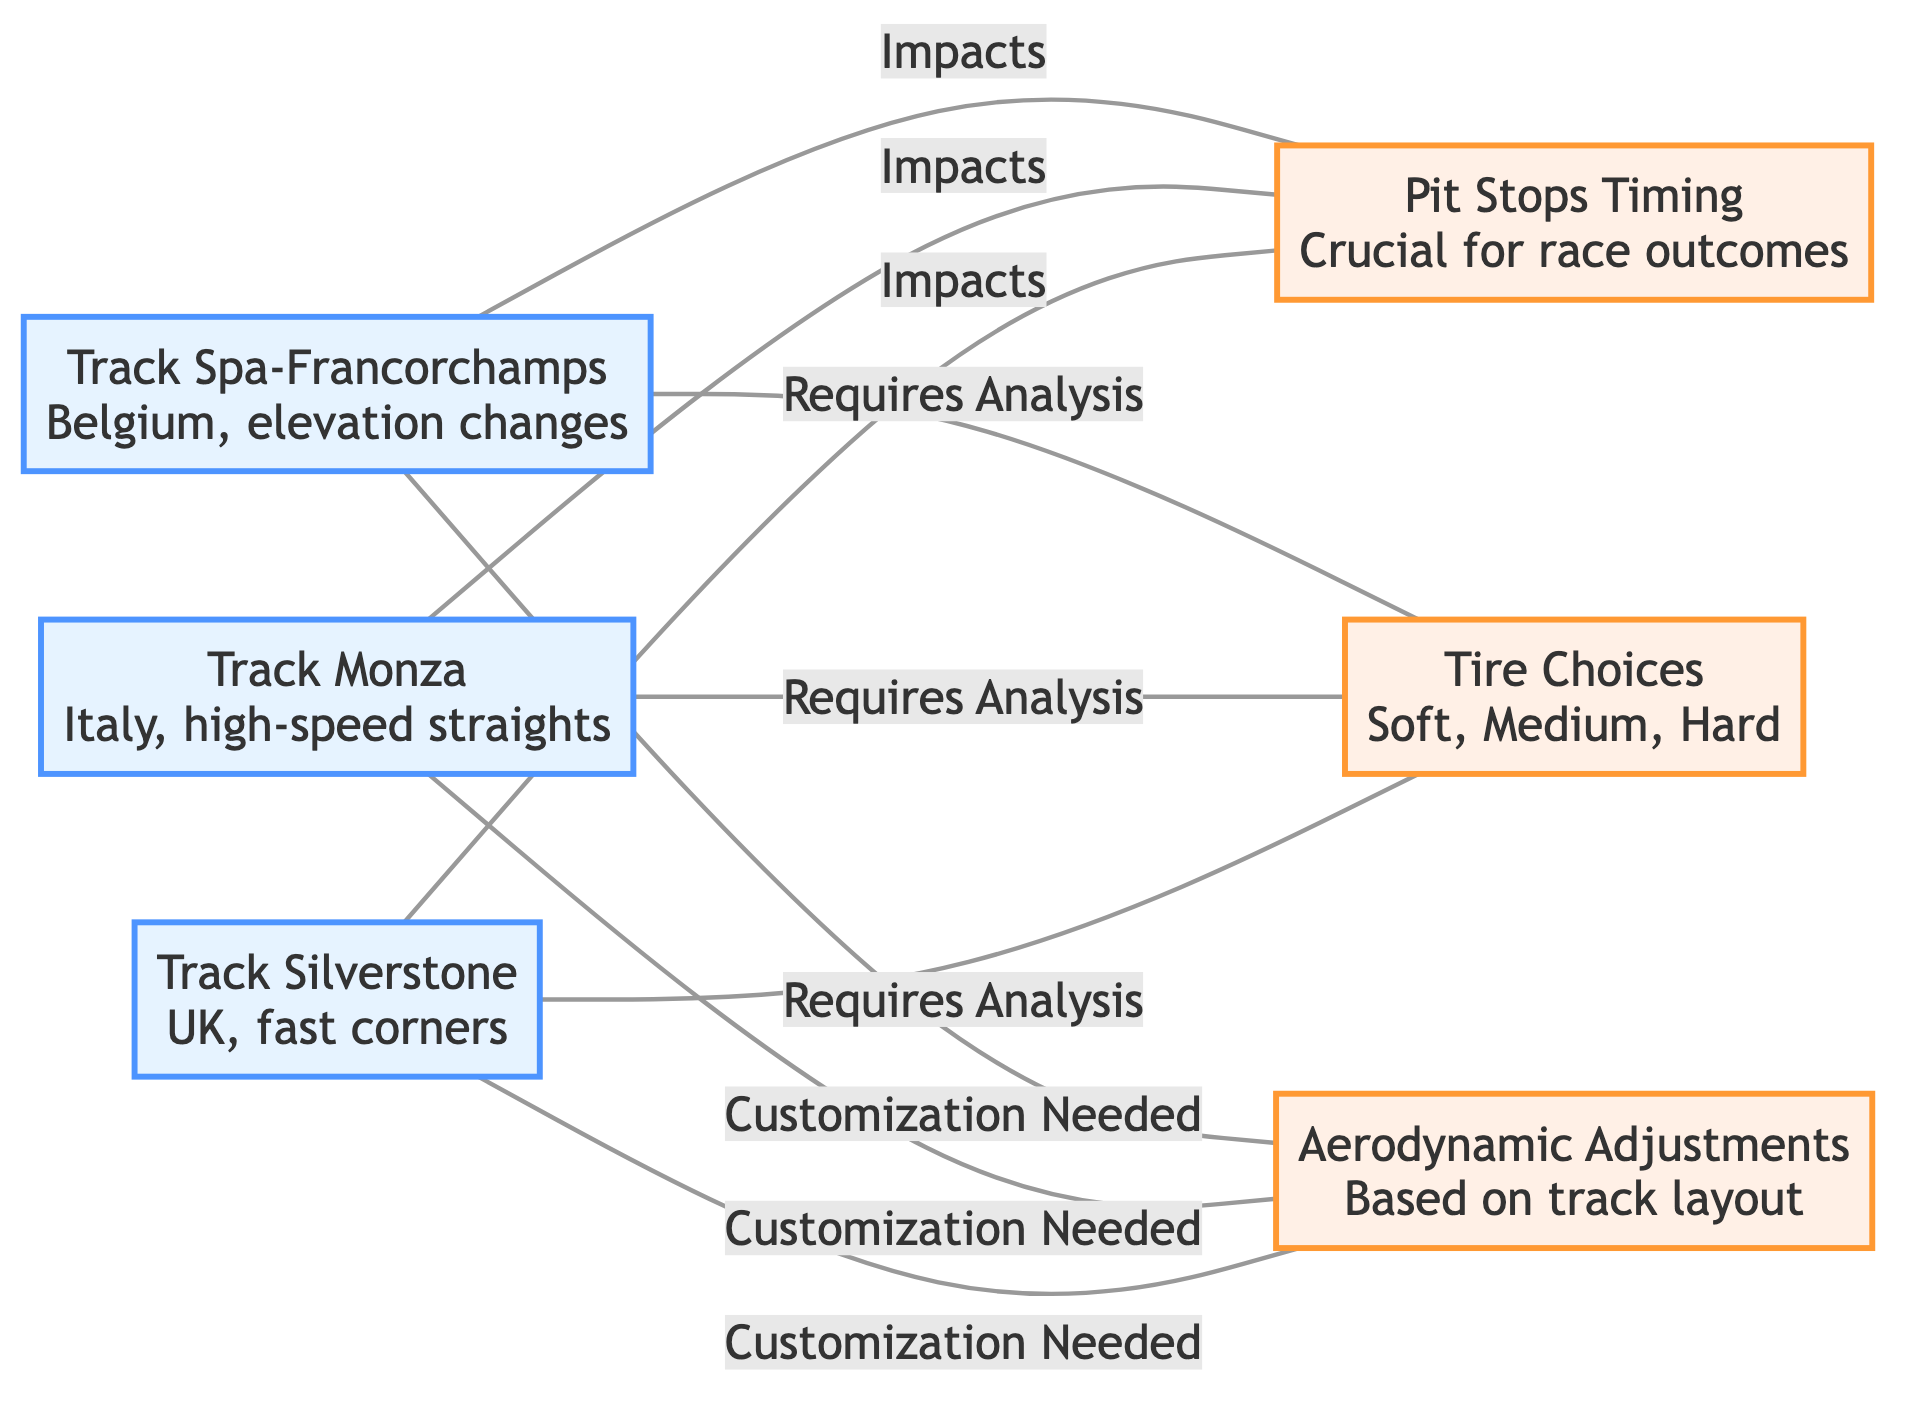What is the total number of nodes in the diagram? The diagram includes three track nodes (Spa-Francorchamps, Monza, Silverstone) and three strategy nodes (Pit Stops Timing, Tire Choices, Aerodynamic Adjustments), totaling six nodes.
Answer: 6 What strategy is linked to Track Spa-Francorchamps? The edges from Track Spa-Francorchamps show links to Pit Stops Timing (impacts), Tire Choices (requires analysis), and Aerodynamic Adjustments (customization needed), indicating these three strategies.
Answer: Pit Stops Timing, Tire Choices, Aerodynamic Adjustments How many edges are associated with Track Monza? The edges linked to Track Monza are similar to those of Track Spa-Francorchamps, which include Pit Stops Timing (impacts), Tire Choices (requires analysis), and Aerodynamic Adjustments (customization needed), resulting in three edges.
Answer: 3 Which track requires analysis for tire choices? The diagram indicates that Tire Choices (requires analysis) is linked to all three tracks: Spa-Francorchamps, Monza, and Silverstone, meaning all these tracks require analysis for tire choices.
Answer: Spa-Francorchamps, Monza, Silverstone What customizations are needed for all tracks? Each track node (Spa-Francorchamps, Monza, Silverstone) has a connection highlighting that Aerodynamic Adjustments (customization needed) are necessary based on the track layout, implying that all require these customizations.
Answer: Aerodynamic Adjustments What is the relationship between Track Silverstone and Pit Stops Timing? The edge connecting Track Silverstone to Pit Stops Timing indicates that its timing has an impact on the race outcome, demonstrating that there is a direct influence from the track on pit strategy.
Answer: Impacts 